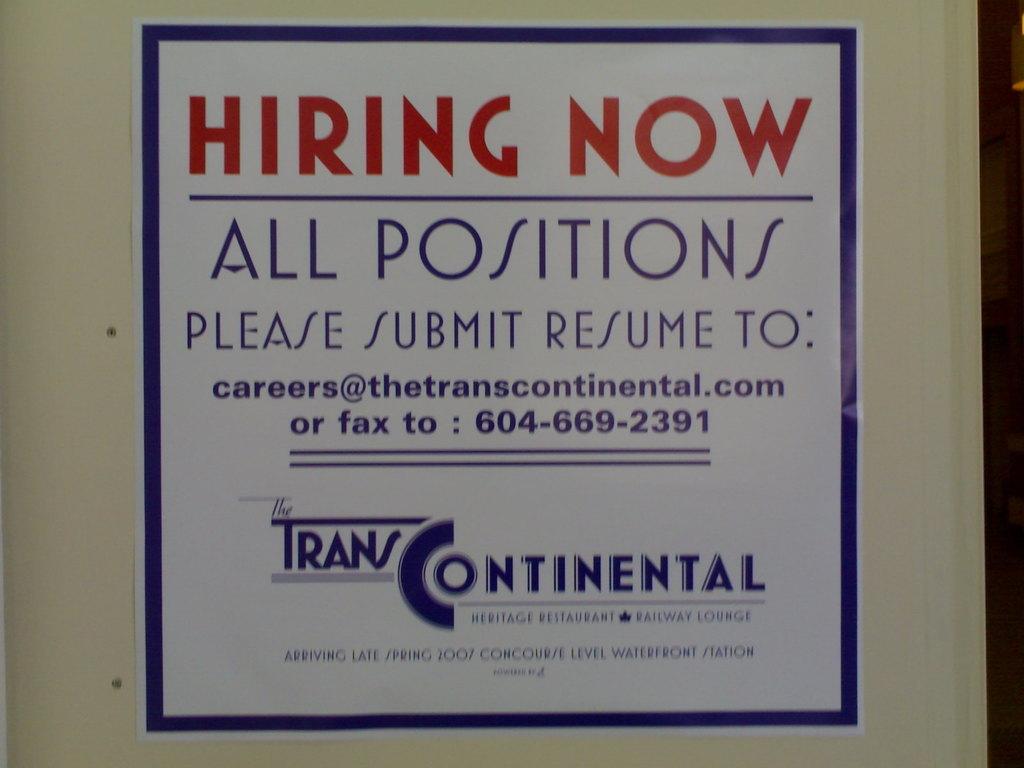What company is hiring?
Offer a terse response. Trans continental. What is the fax number?
Provide a succinct answer. 604-669-2391. 